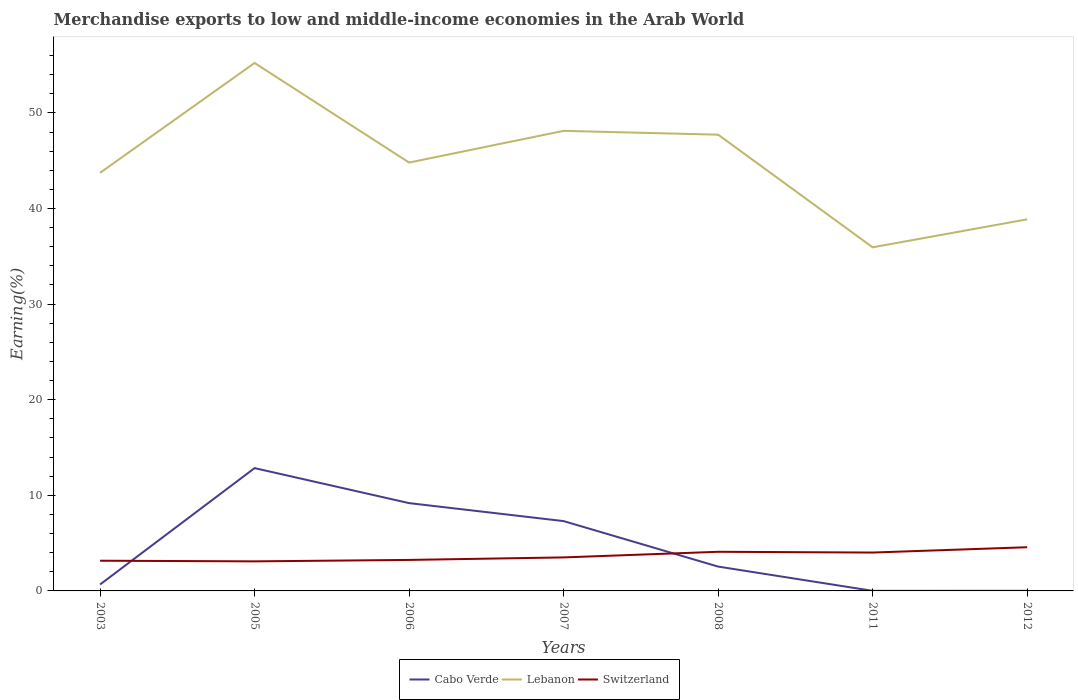Is the number of lines equal to the number of legend labels?
Provide a succinct answer. Yes. Across all years, what is the maximum percentage of amount earned from merchandise exports in Switzerland?
Make the answer very short. 3.09. What is the total percentage of amount earned from merchandise exports in Lebanon in the graph?
Provide a succinct answer. -2.92. What is the difference between the highest and the second highest percentage of amount earned from merchandise exports in Cabo Verde?
Give a very brief answer. 12.84. What is the difference between the highest and the lowest percentage of amount earned from merchandise exports in Cabo Verde?
Give a very brief answer. 3. How many lines are there?
Your response must be concise. 3. How many years are there in the graph?
Your response must be concise. 7. What is the difference between two consecutive major ticks on the Y-axis?
Provide a succinct answer. 10. Are the values on the major ticks of Y-axis written in scientific E-notation?
Offer a very short reply. No. Where does the legend appear in the graph?
Your response must be concise. Bottom center. What is the title of the graph?
Offer a terse response. Merchandise exports to low and middle-income economies in the Arab World. What is the label or title of the X-axis?
Make the answer very short. Years. What is the label or title of the Y-axis?
Keep it short and to the point. Earning(%). What is the Earning(%) in Cabo Verde in 2003?
Your response must be concise. 0.67. What is the Earning(%) of Lebanon in 2003?
Provide a short and direct response. 43.73. What is the Earning(%) in Switzerland in 2003?
Provide a short and direct response. 3.16. What is the Earning(%) of Cabo Verde in 2005?
Offer a very short reply. 12.85. What is the Earning(%) of Lebanon in 2005?
Make the answer very short. 55.22. What is the Earning(%) in Switzerland in 2005?
Keep it short and to the point. 3.09. What is the Earning(%) of Cabo Verde in 2006?
Your response must be concise. 9.18. What is the Earning(%) of Lebanon in 2006?
Give a very brief answer. 44.81. What is the Earning(%) of Switzerland in 2006?
Keep it short and to the point. 3.24. What is the Earning(%) of Cabo Verde in 2007?
Give a very brief answer. 7.3. What is the Earning(%) of Lebanon in 2007?
Ensure brevity in your answer.  48.12. What is the Earning(%) of Switzerland in 2007?
Your answer should be very brief. 3.51. What is the Earning(%) in Cabo Verde in 2008?
Provide a short and direct response. 2.55. What is the Earning(%) in Lebanon in 2008?
Your answer should be compact. 47.72. What is the Earning(%) of Switzerland in 2008?
Your response must be concise. 4.09. What is the Earning(%) of Cabo Verde in 2011?
Your response must be concise. 0.01. What is the Earning(%) of Lebanon in 2011?
Your answer should be compact. 35.94. What is the Earning(%) in Switzerland in 2011?
Provide a succinct answer. 4.01. What is the Earning(%) of Cabo Verde in 2012?
Your response must be concise. 0.01. What is the Earning(%) in Lebanon in 2012?
Your answer should be very brief. 38.87. What is the Earning(%) of Switzerland in 2012?
Keep it short and to the point. 4.57. Across all years, what is the maximum Earning(%) in Cabo Verde?
Ensure brevity in your answer.  12.85. Across all years, what is the maximum Earning(%) of Lebanon?
Offer a terse response. 55.22. Across all years, what is the maximum Earning(%) in Switzerland?
Make the answer very short. 4.57. Across all years, what is the minimum Earning(%) of Cabo Verde?
Ensure brevity in your answer.  0.01. Across all years, what is the minimum Earning(%) of Lebanon?
Your answer should be very brief. 35.94. Across all years, what is the minimum Earning(%) of Switzerland?
Make the answer very short. 3.09. What is the total Earning(%) of Cabo Verde in the graph?
Provide a succinct answer. 32.57. What is the total Earning(%) of Lebanon in the graph?
Provide a succinct answer. 314.42. What is the total Earning(%) in Switzerland in the graph?
Ensure brevity in your answer.  25.68. What is the difference between the Earning(%) in Cabo Verde in 2003 and that in 2005?
Offer a terse response. -12.17. What is the difference between the Earning(%) in Lebanon in 2003 and that in 2005?
Provide a short and direct response. -11.49. What is the difference between the Earning(%) of Switzerland in 2003 and that in 2005?
Give a very brief answer. 0.07. What is the difference between the Earning(%) in Cabo Verde in 2003 and that in 2006?
Ensure brevity in your answer.  -8.51. What is the difference between the Earning(%) in Lebanon in 2003 and that in 2006?
Your response must be concise. -1.07. What is the difference between the Earning(%) in Switzerland in 2003 and that in 2006?
Keep it short and to the point. -0.08. What is the difference between the Earning(%) of Cabo Verde in 2003 and that in 2007?
Provide a succinct answer. -6.63. What is the difference between the Earning(%) of Lebanon in 2003 and that in 2007?
Your answer should be compact. -4.39. What is the difference between the Earning(%) of Switzerland in 2003 and that in 2007?
Give a very brief answer. -0.35. What is the difference between the Earning(%) of Cabo Verde in 2003 and that in 2008?
Your answer should be very brief. -1.87. What is the difference between the Earning(%) of Lebanon in 2003 and that in 2008?
Provide a short and direct response. -3.99. What is the difference between the Earning(%) in Switzerland in 2003 and that in 2008?
Offer a terse response. -0.93. What is the difference between the Earning(%) of Cabo Verde in 2003 and that in 2011?
Ensure brevity in your answer.  0.66. What is the difference between the Earning(%) in Lebanon in 2003 and that in 2011?
Provide a succinct answer. 7.79. What is the difference between the Earning(%) of Switzerland in 2003 and that in 2011?
Provide a short and direct response. -0.86. What is the difference between the Earning(%) in Cabo Verde in 2003 and that in 2012?
Offer a very short reply. 0.66. What is the difference between the Earning(%) of Lebanon in 2003 and that in 2012?
Offer a very short reply. 4.87. What is the difference between the Earning(%) of Switzerland in 2003 and that in 2012?
Make the answer very short. -1.41. What is the difference between the Earning(%) in Cabo Verde in 2005 and that in 2006?
Offer a very short reply. 3.66. What is the difference between the Earning(%) of Lebanon in 2005 and that in 2006?
Offer a terse response. 10.42. What is the difference between the Earning(%) of Switzerland in 2005 and that in 2006?
Offer a very short reply. -0.15. What is the difference between the Earning(%) of Cabo Verde in 2005 and that in 2007?
Your answer should be very brief. 5.54. What is the difference between the Earning(%) in Lebanon in 2005 and that in 2007?
Keep it short and to the point. 7.1. What is the difference between the Earning(%) in Switzerland in 2005 and that in 2007?
Give a very brief answer. -0.41. What is the difference between the Earning(%) of Cabo Verde in 2005 and that in 2008?
Give a very brief answer. 10.3. What is the difference between the Earning(%) of Switzerland in 2005 and that in 2008?
Your answer should be very brief. -1. What is the difference between the Earning(%) in Cabo Verde in 2005 and that in 2011?
Your response must be concise. 12.84. What is the difference between the Earning(%) of Lebanon in 2005 and that in 2011?
Provide a succinct answer. 19.28. What is the difference between the Earning(%) in Switzerland in 2005 and that in 2011?
Make the answer very short. -0.92. What is the difference between the Earning(%) of Cabo Verde in 2005 and that in 2012?
Your response must be concise. 12.83. What is the difference between the Earning(%) of Lebanon in 2005 and that in 2012?
Make the answer very short. 16.36. What is the difference between the Earning(%) in Switzerland in 2005 and that in 2012?
Your answer should be compact. -1.48. What is the difference between the Earning(%) in Cabo Verde in 2006 and that in 2007?
Your answer should be very brief. 1.88. What is the difference between the Earning(%) in Lebanon in 2006 and that in 2007?
Your answer should be very brief. -3.32. What is the difference between the Earning(%) of Switzerland in 2006 and that in 2007?
Provide a short and direct response. -0.26. What is the difference between the Earning(%) of Cabo Verde in 2006 and that in 2008?
Your response must be concise. 6.64. What is the difference between the Earning(%) of Lebanon in 2006 and that in 2008?
Offer a terse response. -2.92. What is the difference between the Earning(%) of Switzerland in 2006 and that in 2008?
Offer a very short reply. -0.85. What is the difference between the Earning(%) of Cabo Verde in 2006 and that in 2011?
Give a very brief answer. 9.18. What is the difference between the Earning(%) of Lebanon in 2006 and that in 2011?
Give a very brief answer. 8.86. What is the difference between the Earning(%) of Switzerland in 2006 and that in 2011?
Your answer should be compact. -0.77. What is the difference between the Earning(%) of Cabo Verde in 2006 and that in 2012?
Give a very brief answer. 9.17. What is the difference between the Earning(%) of Lebanon in 2006 and that in 2012?
Your answer should be very brief. 5.94. What is the difference between the Earning(%) in Switzerland in 2006 and that in 2012?
Offer a very short reply. -1.33. What is the difference between the Earning(%) of Cabo Verde in 2007 and that in 2008?
Provide a succinct answer. 4.76. What is the difference between the Earning(%) of Lebanon in 2007 and that in 2008?
Your response must be concise. 0.4. What is the difference between the Earning(%) of Switzerland in 2007 and that in 2008?
Make the answer very short. -0.59. What is the difference between the Earning(%) in Cabo Verde in 2007 and that in 2011?
Your response must be concise. 7.29. What is the difference between the Earning(%) of Lebanon in 2007 and that in 2011?
Provide a succinct answer. 12.18. What is the difference between the Earning(%) of Switzerland in 2007 and that in 2011?
Provide a short and direct response. -0.51. What is the difference between the Earning(%) in Cabo Verde in 2007 and that in 2012?
Your response must be concise. 7.29. What is the difference between the Earning(%) in Lebanon in 2007 and that in 2012?
Keep it short and to the point. 9.26. What is the difference between the Earning(%) of Switzerland in 2007 and that in 2012?
Offer a terse response. -1.06. What is the difference between the Earning(%) of Cabo Verde in 2008 and that in 2011?
Give a very brief answer. 2.54. What is the difference between the Earning(%) of Lebanon in 2008 and that in 2011?
Your response must be concise. 11.78. What is the difference between the Earning(%) of Switzerland in 2008 and that in 2011?
Ensure brevity in your answer.  0.08. What is the difference between the Earning(%) of Cabo Verde in 2008 and that in 2012?
Keep it short and to the point. 2.53. What is the difference between the Earning(%) in Lebanon in 2008 and that in 2012?
Ensure brevity in your answer.  8.86. What is the difference between the Earning(%) of Switzerland in 2008 and that in 2012?
Provide a short and direct response. -0.48. What is the difference between the Earning(%) of Cabo Verde in 2011 and that in 2012?
Your response must be concise. -0.01. What is the difference between the Earning(%) in Lebanon in 2011 and that in 2012?
Your answer should be very brief. -2.93. What is the difference between the Earning(%) of Switzerland in 2011 and that in 2012?
Offer a very short reply. -0.56. What is the difference between the Earning(%) in Cabo Verde in 2003 and the Earning(%) in Lebanon in 2005?
Offer a terse response. -54.55. What is the difference between the Earning(%) in Cabo Verde in 2003 and the Earning(%) in Switzerland in 2005?
Your answer should be very brief. -2.42. What is the difference between the Earning(%) in Lebanon in 2003 and the Earning(%) in Switzerland in 2005?
Your answer should be very brief. 40.64. What is the difference between the Earning(%) in Cabo Verde in 2003 and the Earning(%) in Lebanon in 2006?
Give a very brief answer. -44.13. What is the difference between the Earning(%) of Cabo Verde in 2003 and the Earning(%) of Switzerland in 2006?
Provide a succinct answer. -2.57. What is the difference between the Earning(%) in Lebanon in 2003 and the Earning(%) in Switzerland in 2006?
Your response must be concise. 40.49. What is the difference between the Earning(%) of Cabo Verde in 2003 and the Earning(%) of Lebanon in 2007?
Your response must be concise. -47.45. What is the difference between the Earning(%) in Cabo Verde in 2003 and the Earning(%) in Switzerland in 2007?
Your answer should be compact. -2.83. What is the difference between the Earning(%) of Lebanon in 2003 and the Earning(%) of Switzerland in 2007?
Your answer should be very brief. 40.23. What is the difference between the Earning(%) in Cabo Verde in 2003 and the Earning(%) in Lebanon in 2008?
Your answer should be compact. -47.05. What is the difference between the Earning(%) of Cabo Verde in 2003 and the Earning(%) of Switzerland in 2008?
Your answer should be compact. -3.42. What is the difference between the Earning(%) in Lebanon in 2003 and the Earning(%) in Switzerland in 2008?
Offer a terse response. 39.64. What is the difference between the Earning(%) in Cabo Verde in 2003 and the Earning(%) in Lebanon in 2011?
Offer a very short reply. -35.27. What is the difference between the Earning(%) of Cabo Verde in 2003 and the Earning(%) of Switzerland in 2011?
Offer a terse response. -3.34. What is the difference between the Earning(%) in Lebanon in 2003 and the Earning(%) in Switzerland in 2011?
Offer a very short reply. 39.72. What is the difference between the Earning(%) of Cabo Verde in 2003 and the Earning(%) of Lebanon in 2012?
Make the answer very short. -38.19. What is the difference between the Earning(%) in Cabo Verde in 2003 and the Earning(%) in Switzerland in 2012?
Provide a succinct answer. -3.9. What is the difference between the Earning(%) of Lebanon in 2003 and the Earning(%) of Switzerland in 2012?
Keep it short and to the point. 39.16. What is the difference between the Earning(%) of Cabo Verde in 2005 and the Earning(%) of Lebanon in 2006?
Ensure brevity in your answer.  -31.96. What is the difference between the Earning(%) in Cabo Verde in 2005 and the Earning(%) in Switzerland in 2006?
Give a very brief answer. 9.6. What is the difference between the Earning(%) of Lebanon in 2005 and the Earning(%) of Switzerland in 2006?
Provide a succinct answer. 51.98. What is the difference between the Earning(%) in Cabo Verde in 2005 and the Earning(%) in Lebanon in 2007?
Ensure brevity in your answer.  -35.28. What is the difference between the Earning(%) in Cabo Verde in 2005 and the Earning(%) in Switzerland in 2007?
Keep it short and to the point. 9.34. What is the difference between the Earning(%) in Lebanon in 2005 and the Earning(%) in Switzerland in 2007?
Keep it short and to the point. 51.72. What is the difference between the Earning(%) in Cabo Verde in 2005 and the Earning(%) in Lebanon in 2008?
Ensure brevity in your answer.  -34.88. What is the difference between the Earning(%) in Cabo Verde in 2005 and the Earning(%) in Switzerland in 2008?
Your answer should be very brief. 8.75. What is the difference between the Earning(%) in Lebanon in 2005 and the Earning(%) in Switzerland in 2008?
Give a very brief answer. 51.13. What is the difference between the Earning(%) of Cabo Verde in 2005 and the Earning(%) of Lebanon in 2011?
Your answer should be compact. -23.09. What is the difference between the Earning(%) in Cabo Verde in 2005 and the Earning(%) in Switzerland in 2011?
Offer a terse response. 8.83. What is the difference between the Earning(%) of Lebanon in 2005 and the Earning(%) of Switzerland in 2011?
Your response must be concise. 51.21. What is the difference between the Earning(%) of Cabo Verde in 2005 and the Earning(%) of Lebanon in 2012?
Make the answer very short. -26.02. What is the difference between the Earning(%) of Cabo Verde in 2005 and the Earning(%) of Switzerland in 2012?
Ensure brevity in your answer.  8.28. What is the difference between the Earning(%) of Lebanon in 2005 and the Earning(%) of Switzerland in 2012?
Keep it short and to the point. 50.65. What is the difference between the Earning(%) in Cabo Verde in 2006 and the Earning(%) in Lebanon in 2007?
Your answer should be compact. -38.94. What is the difference between the Earning(%) in Cabo Verde in 2006 and the Earning(%) in Switzerland in 2007?
Your answer should be compact. 5.68. What is the difference between the Earning(%) of Lebanon in 2006 and the Earning(%) of Switzerland in 2007?
Ensure brevity in your answer.  41.3. What is the difference between the Earning(%) in Cabo Verde in 2006 and the Earning(%) in Lebanon in 2008?
Your answer should be very brief. -38.54. What is the difference between the Earning(%) in Cabo Verde in 2006 and the Earning(%) in Switzerland in 2008?
Give a very brief answer. 5.09. What is the difference between the Earning(%) in Lebanon in 2006 and the Earning(%) in Switzerland in 2008?
Provide a succinct answer. 40.71. What is the difference between the Earning(%) of Cabo Verde in 2006 and the Earning(%) of Lebanon in 2011?
Keep it short and to the point. -26.76. What is the difference between the Earning(%) in Cabo Verde in 2006 and the Earning(%) in Switzerland in 2011?
Ensure brevity in your answer.  5.17. What is the difference between the Earning(%) of Lebanon in 2006 and the Earning(%) of Switzerland in 2011?
Offer a very short reply. 40.79. What is the difference between the Earning(%) in Cabo Verde in 2006 and the Earning(%) in Lebanon in 2012?
Keep it short and to the point. -29.68. What is the difference between the Earning(%) of Cabo Verde in 2006 and the Earning(%) of Switzerland in 2012?
Your answer should be compact. 4.62. What is the difference between the Earning(%) of Lebanon in 2006 and the Earning(%) of Switzerland in 2012?
Keep it short and to the point. 40.24. What is the difference between the Earning(%) in Cabo Verde in 2007 and the Earning(%) in Lebanon in 2008?
Make the answer very short. -40.42. What is the difference between the Earning(%) of Cabo Verde in 2007 and the Earning(%) of Switzerland in 2008?
Give a very brief answer. 3.21. What is the difference between the Earning(%) in Lebanon in 2007 and the Earning(%) in Switzerland in 2008?
Offer a very short reply. 44.03. What is the difference between the Earning(%) of Cabo Verde in 2007 and the Earning(%) of Lebanon in 2011?
Your answer should be very brief. -28.64. What is the difference between the Earning(%) of Cabo Verde in 2007 and the Earning(%) of Switzerland in 2011?
Ensure brevity in your answer.  3.29. What is the difference between the Earning(%) of Lebanon in 2007 and the Earning(%) of Switzerland in 2011?
Provide a succinct answer. 44.11. What is the difference between the Earning(%) of Cabo Verde in 2007 and the Earning(%) of Lebanon in 2012?
Ensure brevity in your answer.  -31.56. What is the difference between the Earning(%) in Cabo Verde in 2007 and the Earning(%) in Switzerland in 2012?
Provide a succinct answer. 2.73. What is the difference between the Earning(%) of Lebanon in 2007 and the Earning(%) of Switzerland in 2012?
Offer a very short reply. 43.55. What is the difference between the Earning(%) in Cabo Verde in 2008 and the Earning(%) in Lebanon in 2011?
Ensure brevity in your answer.  -33.4. What is the difference between the Earning(%) of Cabo Verde in 2008 and the Earning(%) of Switzerland in 2011?
Your answer should be compact. -1.47. What is the difference between the Earning(%) of Lebanon in 2008 and the Earning(%) of Switzerland in 2011?
Keep it short and to the point. 43.71. What is the difference between the Earning(%) of Cabo Verde in 2008 and the Earning(%) of Lebanon in 2012?
Offer a terse response. -36.32. What is the difference between the Earning(%) of Cabo Verde in 2008 and the Earning(%) of Switzerland in 2012?
Provide a succinct answer. -2.02. What is the difference between the Earning(%) in Lebanon in 2008 and the Earning(%) in Switzerland in 2012?
Offer a terse response. 43.15. What is the difference between the Earning(%) of Cabo Verde in 2011 and the Earning(%) of Lebanon in 2012?
Provide a succinct answer. -38.86. What is the difference between the Earning(%) of Cabo Verde in 2011 and the Earning(%) of Switzerland in 2012?
Your answer should be very brief. -4.56. What is the difference between the Earning(%) in Lebanon in 2011 and the Earning(%) in Switzerland in 2012?
Ensure brevity in your answer.  31.37. What is the average Earning(%) in Cabo Verde per year?
Ensure brevity in your answer.  4.65. What is the average Earning(%) in Lebanon per year?
Keep it short and to the point. 44.92. What is the average Earning(%) in Switzerland per year?
Your response must be concise. 3.67. In the year 2003, what is the difference between the Earning(%) of Cabo Verde and Earning(%) of Lebanon?
Ensure brevity in your answer.  -43.06. In the year 2003, what is the difference between the Earning(%) of Cabo Verde and Earning(%) of Switzerland?
Keep it short and to the point. -2.49. In the year 2003, what is the difference between the Earning(%) in Lebanon and Earning(%) in Switzerland?
Offer a very short reply. 40.57. In the year 2005, what is the difference between the Earning(%) of Cabo Verde and Earning(%) of Lebanon?
Offer a very short reply. -42.38. In the year 2005, what is the difference between the Earning(%) of Cabo Verde and Earning(%) of Switzerland?
Offer a very short reply. 9.75. In the year 2005, what is the difference between the Earning(%) of Lebanon and Earning(%) of Switzerland?
Make the answer very short. 52.13. In the year 2006, what is the difference between the Earning(%) in Cabo Verde and Earning(%) in Lebanon?
Provide a short and direct response. -35.62. In the year 2006, what is the difference between the Earning(%) in Cabo Verde and Earning(%) in Switzerland?
Your answer should be very brief. 5.94. In the year 2006, what is the difference between the Earning(%) in Lebanon and Earning(%) in Switzerland?
Keep it short and to the point. 41.56. In the year 2007, what is the difference between the Earning(%) in Cabo Verde and Earning(%) in Lebanon?
Offer a terse response. -40.82. In the year 2007, what is the difference between the Earning(%) in Cabo Verde and Earning(%) in Switzerland?
Keep it short and to the point. 3.8. In the year 2007, what is the difference between the Earning(%) in Lebanon and Earning(%) in Switzerland?
Your response must be concise. 44.62. In the year 2008, what is the difference between the Earning(%) of Cabo Verde and Earning(%) of Lebanon?
Give a very brief answer. -45.18. In the year 2008, what is the difference between the Earning(%) in Cabo Verde and Earning(%) in Switzerland?
Offer a terse response. -1.55. In the year 2008, what is the difference between the Earning(%) in Lebanon and Earning(%) in Switzerland?
Give a very brief answer. 43.63. In the year 2011, what is the difference between the Earning(%) in Cabo Verde and Earning(%) in Lebanon?
Provide a short and direct response. -35.93. In the year 2011, what is the difference between the Earning(%) of Cabo Verde and Earning(%) of Switzerland?
Give a very brief answer. -4.01. In the year 2011, what is the difference between the Earning(%) in Lebanon and Earning(%) in Switzerland?
Your answer should be compact. 31.93. In the year 2012, what is the difference between the Earning(%) in Cabo Verde and Earning(%) in Lebanon?
Keep it short and to the point. -38.85. In the year 2012, what is the difference between the Earning(%) of Cabo Verde and Earning(%) of Switzerland?
Ensure brevity in your answer.  -4.56. In the year 2012, what is the difference between the Earning(%) in Lebanon and Earning(%) in Switzerland?
Your answer should be very brief. 34.3. What is the ratio of the Earning(%) of Cabo Verde in 2003 to that in 2005?
Make the answer very short. 0.05. What is the ratio of the Earning(%) of Lebanon in 2003 to that in 2005?
Keep it short and to the point. 0.79. What is the ratio of the Earning(%) of Switzerland in 2003 to that in 2005?
Give a very brief answer. 1.02. What is the ratio of the Earning(%) in Cabo Verde in 2003 to that in 2006?
Ensure brevity in your answer.  0.07. What is the ratio of the Earning(%) in Switzerland in 2003 to that in 2006?
Offer a very short reply. 0.97. What is the ratio of the Earning(%) in Cabo Verde in 2003 to that in 2007?
Keep it short and to the point. 0.09. What is the ratio of the Earning(%) of Lebanon in 2003 to that in 2007?
Provide a short and direct response. 0.91. What is the ratio of the Earning(%) of Switzerland in 2003 to that in 2007?
Give a very brief answer. 0.9. What is the ratio of the Earning(%) in Cabo Verde in 2003 to that in 2008?
Provide a succinct answer. 0.26. What is the ratio of the Earning(%) in Lebanon in 2003 to that in 2008?
Ensure brevity in your answer.  0.92. What is the ratio of the Earning(%) of Switzerland in 2003 to that in 2008?
Your answer should be compact. 0.77. What is the ratio of the Earning(%) of Cabo Verde in 2003 to that in 2011?
Ensure brevity in your answer.  80.78. What is the ratio of the Earning(%) in Lebanon in 2003 to that in 2011?
Provide a succinct answer. 1.22. What is the ratio of the Earning(%) in Switzerland in 2003 to that in 2011?
Make the answer very short. 0.79. What is the ratio of the Earning(%) of Cabo Verde in 2003 to that in 2012?
Keep it short and to the point. 49.16. What is the ratio of the Earning(%) of Lebanon in 2003 to that in 2012?
Provide a short and direct response. 1.13. What is the ratio of the Earning(%) in Switzerland in 2003 to that in 2012?
Keep it short and to the point. 0.69. What is the ratio of the Earning(%) of Cabo Verde in 2005 to that in 2006?
Give a very brief answer. 1.4. What is the ratio of the Earning(%) of Lebanon in 2005 to that in 2006?
Ensure brevity in your answer.  1.23. What is the ratio of the Earning(%) in Switzerland in 2005 to that in 2006?
Offer a very short reply. 0.95. What is the ratio of the Earning(%) of Cabo Verde in 2005 to that in 2007?
Provide a short and direct response. 1.76. What is the ratio of the Earning(%) in Lebanon in 2005 to that in 2007?
Your response must be concise. 1.15. What is the ratio of the Earning(%) in Switzerland in 2005 to that in 2007?
Your answer should be very brief. 0.88. What is the ratio of the Earning(%) in Cabo Verde in 2005 to that in 2008?
Your answer should be compact. 5.05. What is the ratio of the Earning(%) of Lebanon in 2005 to that in 2008?
Your response must be concise. 1.16. What is the ratio of the Earning(%) in Switzerland in 2005 to that in 2008?
Ensure brevity in your answer.  0.76. What is the ratio of the Earning(%) of Cabo Verde in 2005 to that in 2011?
Offer a very short reply. 1542.81. What is the ratio of the Earning(%) in Lebanon in 2005 to that in 2011?
Your response must be concise. 1.54. What is the ratio of the Earning(%) of Switzerland in 2005 to that in 2011?
Give a very brief answer. 0.77. What is the ratio of the Earning(%) of Cabo Verde in 2005 to that in 2012?
Keep it short and to the point. 938.94. What is the ratio of the Earning(%) in Lebanon in 2005 to that in 2012?
Offer a terse response. 1.42. What is the ratio of the Earning(%) in Switzerland in 2005 to that in 2012?
Offer a terse response. 0.68. What is the ratio of the Earning(%) of Cabo Verde in 2006 to that in 2007?
Give a very brief answer. 1.26. What is the ratio of the Earning(%) of Lebanon in 2006 to that in 2007?
Offer a very short reply. 0.93. What is the ratio of the Earning(%) in Switzerland in 2006 to that in 2007?
Your answer should be compact. 0.93. What is the ratio of the Earning(%) in Cabo Verde in 2006 to that in 2008?
Make the answer very short. 3.61. What is the ratio of the Earning(%) of Lebanon in 2006 to that in 2008?
Your answer should be very brief. 0.94. What is the ratio of the Earning(%) in Switzerland in 2006 to that in 2008?
Your answer should be compact. 0.79. What is the ratio of the Earning(%) in Cabo Verde in 2006 to that in 2011?
Offer a terse response. 1103.05. What is the ratio of the Earning(%) in Lebanon in 2006 to that in 2011?
Provide a short and direct response. 1.25. What is the ratio of the Earning(%) in Switzerland in 2006 to that in 2011?
Offer a very short reply. 0.81. What is the ratio of the Earning(%) of Cabo Verde in 2006 to that in 2012?
Offer a terse response. 671.31. What is the ratio of the Earning(%) in Lebanon in 2006 to that in 2012?
Offer a very short reply. 1.15. What is the ratio of the Earning(%) in Switzerland in 2006 to that in 2012?
Offer a very short reply. 0.71. What is the ratio of the Earning(%) in Cabo Verde in 2007 to that in 2008?
Your answer should be very brief. 2.87. What is the ratio of the Earning(%) in Lebanon in 2007 to that in 2008?
Provide a short and direct response. 1.01. What is the ratio of the Earning(%) of Switzerland in 2007 to that in 2008?
Offer a terse response. 0.86. What is the ratio of the Earning(%) of Cabo Verde in 2007 to that in 2011?
Offer a very short reply. 877.03. What is the ratio of the Earning(%) in Lebanon in 2007 to that in 2011?
Ensure brevity in your answer.  1.34. What is the ratio of the Earning(%) of Switzerland in 2007 to that in 2011?
Provide a short and direct response. 0.87. What is the ratio of the Earning(%) in Cabo Verde in 2007 to that in 2012?
Your answer should be compact. 533.76. What is the ratio of the Earning(%) of Lebanon in 2007 to that in 2012?
Keep it short and to the point. 1.24. What is the ratio of the Earning(%) in Switzerland in 2007 to that in 2012?
Offer a terse response. 0.77. What is the ratio of the Earning(%) of Cabo Verde in 2008 to that in 2011?
Ensure brevity in your answer.  305.77. What is the ratio of the Earning(%) of Lebanon in 2008 to that in 2011?
Provide a short and direct response. 1.33. What is the ratio of the Earning(%) of Switzerland in 2008 to that in 2011?
Your answer should be very brief. 1.02. What is the ratio of the Earning(%) in Cabo Verde in 2008 to that in 2012?
Make the answer very short. 186.09. What is the ratio of the Earning(%) of Lebanon in 2008 to that in 2012?
Ensure brevity in your answer.  1.23. What is the ratio of the Earning(%) of Switzerland in 2008 to that in 2012?
Your answer should be compact. 0.9. What is the ratio of the Earning(%) of Cabo Verde in 2011 to that in 2012?
Make the answer very short. 0.61. What is the ratio of the Earning(%) of Lebanon in 2011 to that in 2012?
Keep it short and to the point. 0.92. What is the ratio of the Earning(%) in Switzerland in 2011 to that in 2012?
Keep it short and to the point. 0.88. What is the difference between the highest and the second highest Earning(%) in Cabo Verde?
Provide a succinct answer. 3.66. What is the difference between the highest and the second highest Earning(%) in Lebanon?
Offer a very short reply. 7.1. What is the difference between the highest and the second highest Earning(%) in Switzerland?
Provide a short and direct response. 0.48. What is the difference between the highest and the lowest Earning(%) in Cabo Verde?
Ensure brevity in your answer.  12.84. What is the difference between the highest and the lowest Earning(%) of Lebanon?
Provide a short and direct response. 19.28. What is the difference between the highest and the lowest Earning(%) of Switzerland?
Make the answer very short. 1.48. 